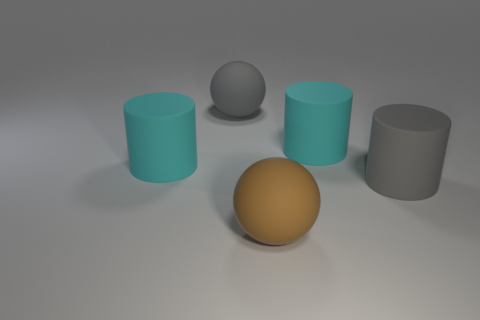What number of shiny things are green cubes or brown spheres?
Make the answer very short. 0. There is a cyan thing to the right of the big brown matte ball; is there a cyan thing to the left of it?
Offer a very short reply. Yes. Are the brown object in front of the large gray matte ball and the big gray cylinder made of the same material?
Your response must be concise. Yes. There is a gray object that is on the right side of the large rubber sphere that is right of the gray sphere; how big is it?
Provide a succinct answer. Large. Do the sphere to the left of the big brown matte thing and the big cyan cylinder that is left of the brown rubber sphere have the same material?
Your answer should be very brief. Yes. There is a brown rubber sphere; what number of rubber things are behind it?
Make the answer very short. 4. Is the brown ball made of the same material as the big gray thing on the left side of the large brown matte sphere?
Keep it short and to the point. Yes. What size is the brown object that is the same material as the big gray cylinder?
Offer a very short reply. Large. Are there more spheres in front of the gray matte cylinder than big gray matte spheres that are in front of the big brown rubber ball?
Your response must be concise. Yes. Is there a large cyan matte object of the same shape as the brown matte object?
Your answer should be very brief. No. 